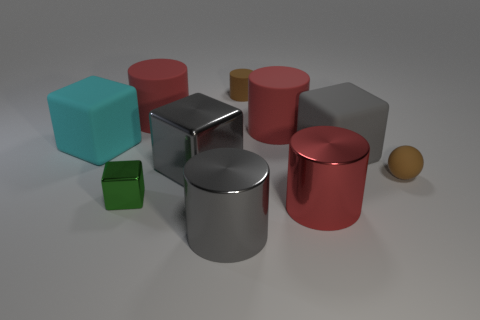The red rubber object that is on the left side of the big gray metal cylinder has what shape? The red object positioned to the left of the large gray metal cylinder is a cylinder itself, mirroring the shape but differing in color and material. 